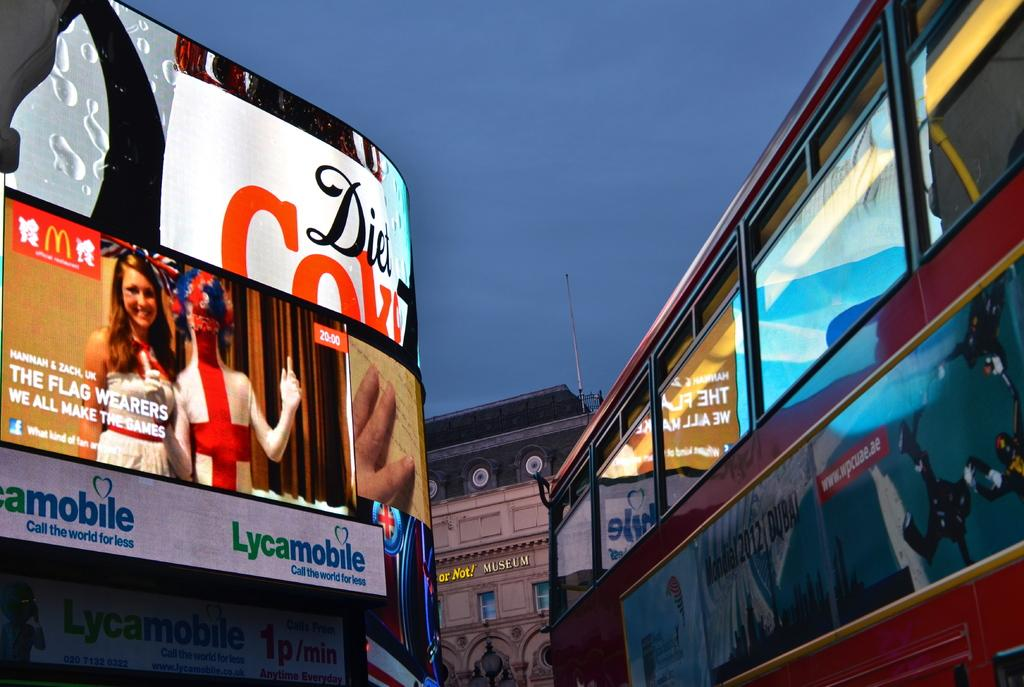Provide a one-sentence caption for the provided image. A Diet Coke billboard lights up in the dusk. 